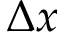Convert formula to latex. <formula><loc_0><loc_0><loc_500><loc_500>\Delta x</formula> 